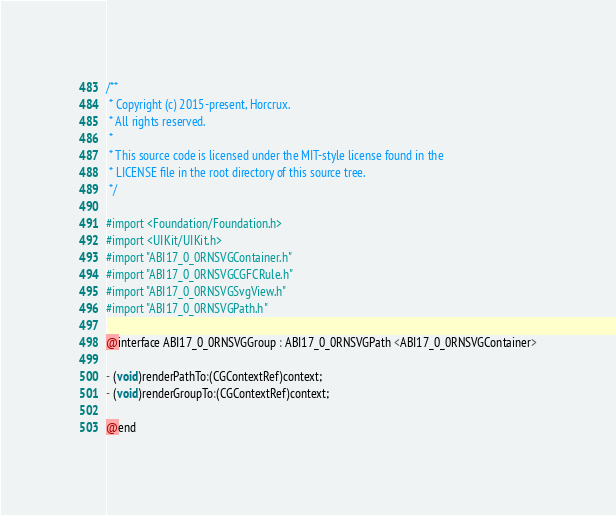Convert code to text. <code><loc_0><loc_0><loc_500><loc_500><_C_>/**
 * Copyright (c) 2015-present, Horcrux.
 * All rights reserved.
 *
 * This source code is licensed under the MIT-style license found in the
 * LICENSE file in the root directory of this source tree.
 */

#import <Foundation/Foundation.h>
#import <UIKit/UIKit.h>
#import "ABI17_0_0RNSVGContainer.h"
#import "ABI17_0_0RNSVGCGFCRule.h"
#import "ABI17_0_0RNSVGSvgView.h"
#import "ABI17_0_0RNSVGPath.h"

@interface ABI17_0_0RNSVGGroup : ABI17_0_0RNSVGPath <ABI17_0_0RNSVGContainer>

- (void)renderPathTo:(CGContextRef)context;
- (void)renderGroupTo:(CGContextRef)context;

@end
</code> 